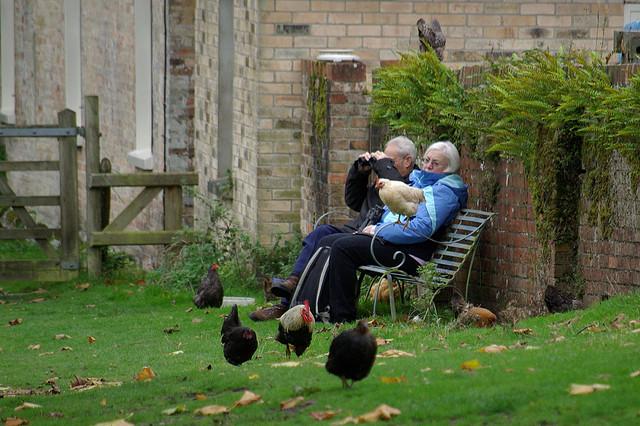What animal is on the woman's arm?
Give a very brief answer. Chicken. What does the man have in his hands?
Quick response, please. Binoculars. Are these pets?
Concise answer only. Yes. What kind of animal is this?
Short answer required. Chicken. 